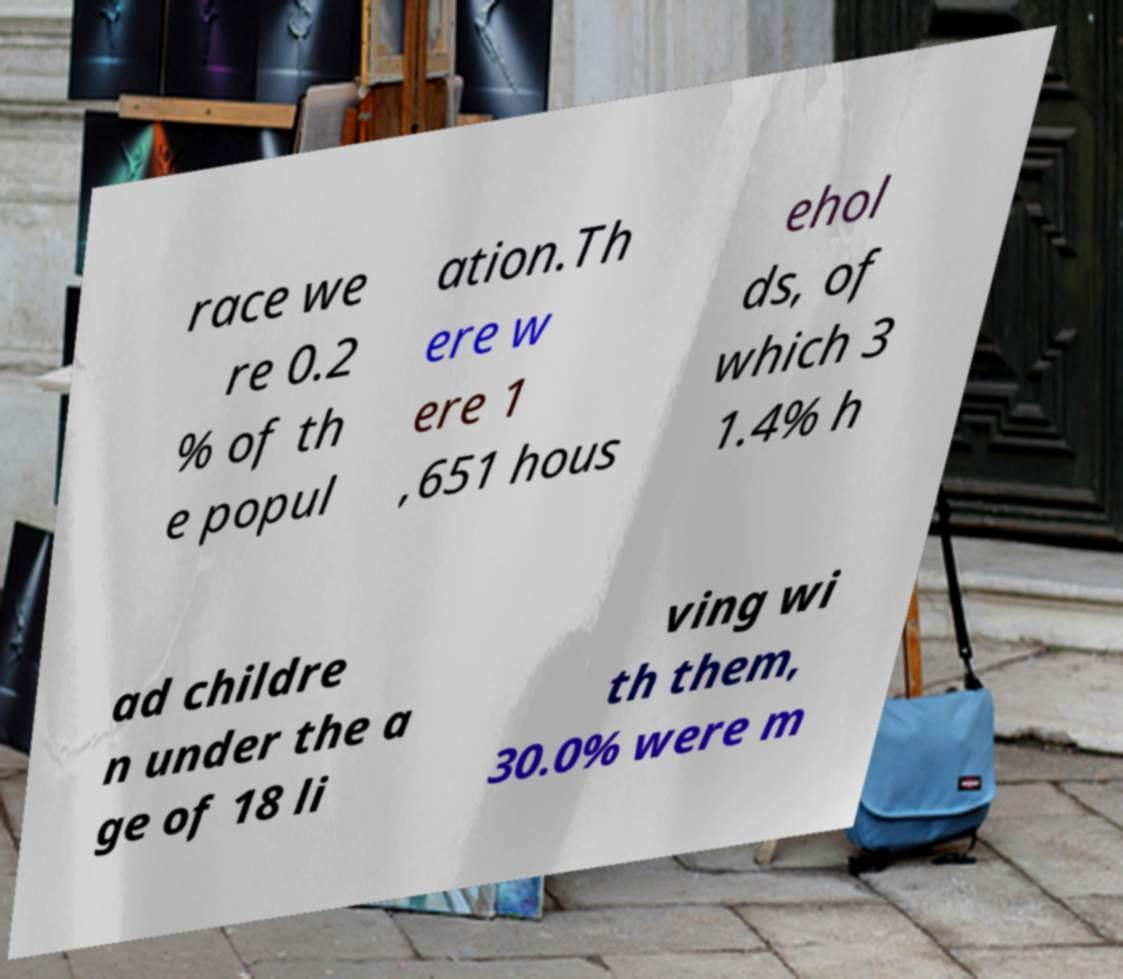Could you extract and type out the text from this image? race we re 0.2 % of th e popul ation.Th ere w ere 1 ,651 hous ehol ds, of which 3 1.4% h ad childre n under the a ge of 18 li ving wi th them, 30.0% were m 